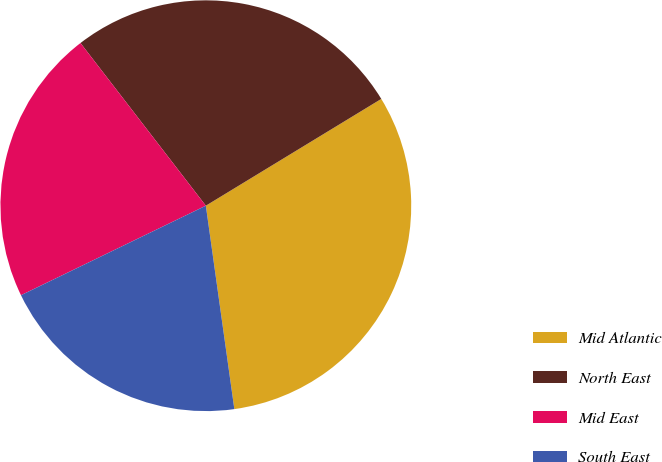Convert chart to OTSL. <chart><loc_0><loc_0><loc_500><loc_500><pie_chart><fcel>Mid Atlantic<fcel>North East<fcel>Mid East<fcel>South East<nl><fcel>31.49%<fcel>26.75%<fcel>21.73%<fcel>20.04%<nl></chart> 